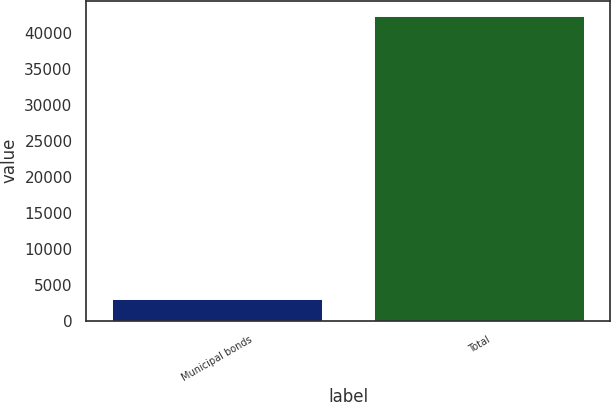Convert chart to OTSL. <chart><loc_0><loc_0><loc_500><loc_500><bar_chart><fcel>Municipal bonds<fcel>Total<nl><fcel>3005<fcel>42406<nl></chart> 